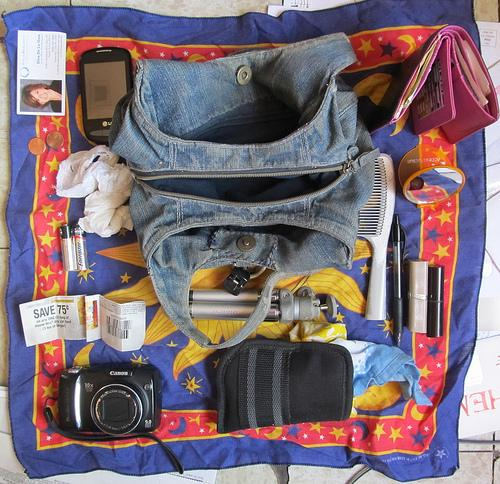What type of purse is depicted in the image? The purse is a blue denim handbag with a button. Identify the color and type of the camera in the image. The camera is a small black point and shoot camera with a lanyard. Can you describe what is on the coupon in the image? The coupon is for 75 cents off and has the word "save" on it. Describe the quality of the image based on its representation of the objects. The image is of good quality, as it clearly displays various objects and their positions in a detailed manner. What is the sentiment of this image? Neutral, as it features various objects with no particular emotional context. Count the types of objects included in the image. There are 14 types of objects including a camera, a comb, batteries, a wallet, a tissue, a pen, lipsticks, a coupon, a purse, a business card, a phone, pennies, a mirror, and a blanket. What type of tasks can use the information in the image to generate reasoning questions? Complex reasoning tasks are suitable for generating questions based on the image's information. How many AA batteries are included in the image? There are two AA batteries on the cloth. What color is the wallet, and where is it positioned? The wallet is pink and is standing on its side on the cloth. What type of card is beside the cell phone in the image? A rectangular identification card with a headshot is next to the cell phone. 